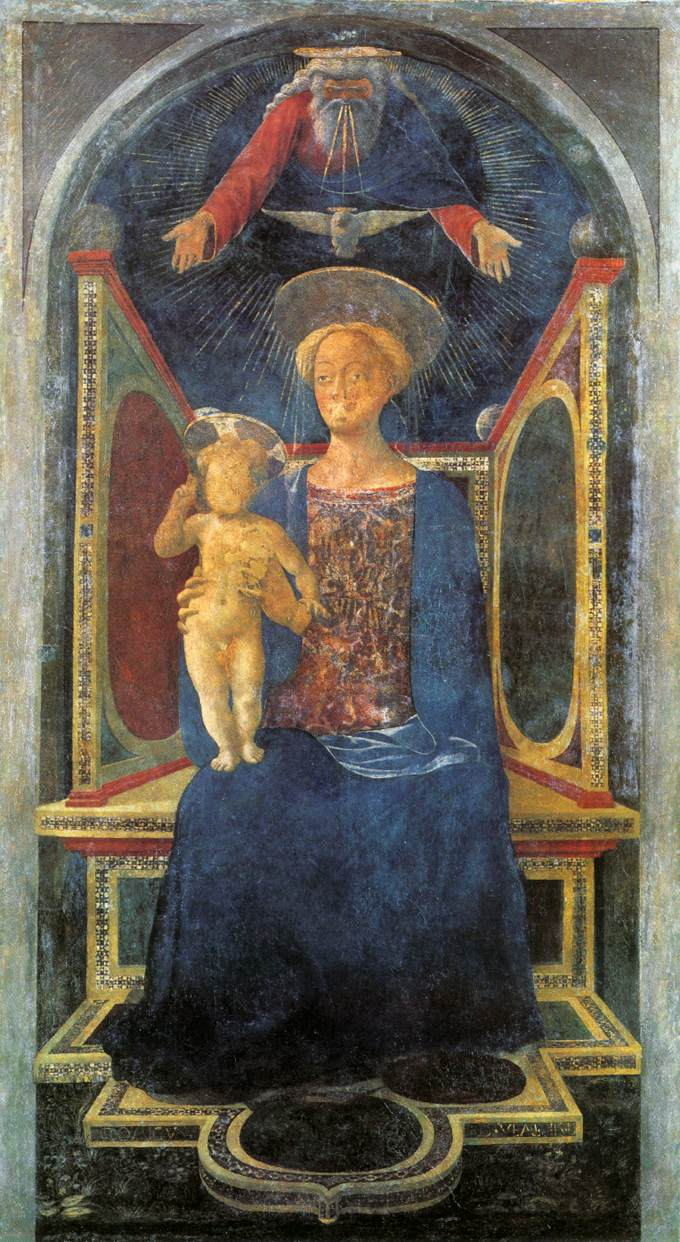What details can you tell me about the figures in this painting? The painting prominently features the Virgin Mary and baby Jesus. The Virgin Mary is seated on a throne, symbolizing her status and importance in Christian theology. She is dressed in a blue robe, which is often associated with purity. Baby Jesus is depicted in her lap, with a tender expression, symbolizing innocence and the divine connection between mother and child. Above them, there is an ethereal representation of God the Father, adding a spiritual element to the scene. What significance does the blue robe of the Virgin Mary hold? In Christian art, the blue robe of the Virgin Mary is rich with symbolic meaning. Blue is often associated with purity, faithfulness, and the divine. It reflects Mary's role as the Mother of God and her purity and virtue. The use of blue, especially in medieval and Renaissance art, also emphasizes her closeness to the heavens, underscoring her importance in Christian belief. Can you describe the environment around the Virgin Mary and baby Jesus? Surrounding the Virgin Mary and baby Jesus is a serene and celestial environment. The backdrop consists of a blue sky dotted with golden stars, symbolizing the heavens. The ornate throne on which Mary is seated is decorated with intricate gold and red patterns, conveying a sense of royalty and divine grace. The archway framing the scene is also adorned with gold, enhancing the overall opulent and holy ambiance of the artwork. Imagine if this painting could tell its own story. What might it say? If this painting could tell its own story, it might say, 'I am a testament to faith and divinity. In me, you see the Virgin Mary, the epitome of purity and grace, cradling the innocent baby Jesus, symbolizing hope and salvation. Above them, the presence of God the Father watches over, uniting the celestial with the earthly. Each brushstroke and hue of blue, gold, and red speaks of devotion and reverence, a timeless reminder of the sacred bond between the divine and humanity.' 